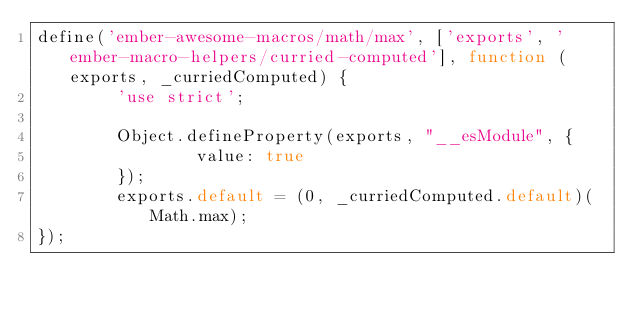<code> <loc_0><loc_0><loc_500><loc_500><_JavaScript_>define('ember-awesome-macros/math/max', ['exports', 'ember-macro-helpers/curried-computed'], function (exports, _curriedComputed) {
        'use strict';

        Object.defineProperty(exports, "__esModule", {
                value: true
        });
        exports.default = (0, _curriedComputed.default)(Math.max);
});</code> 